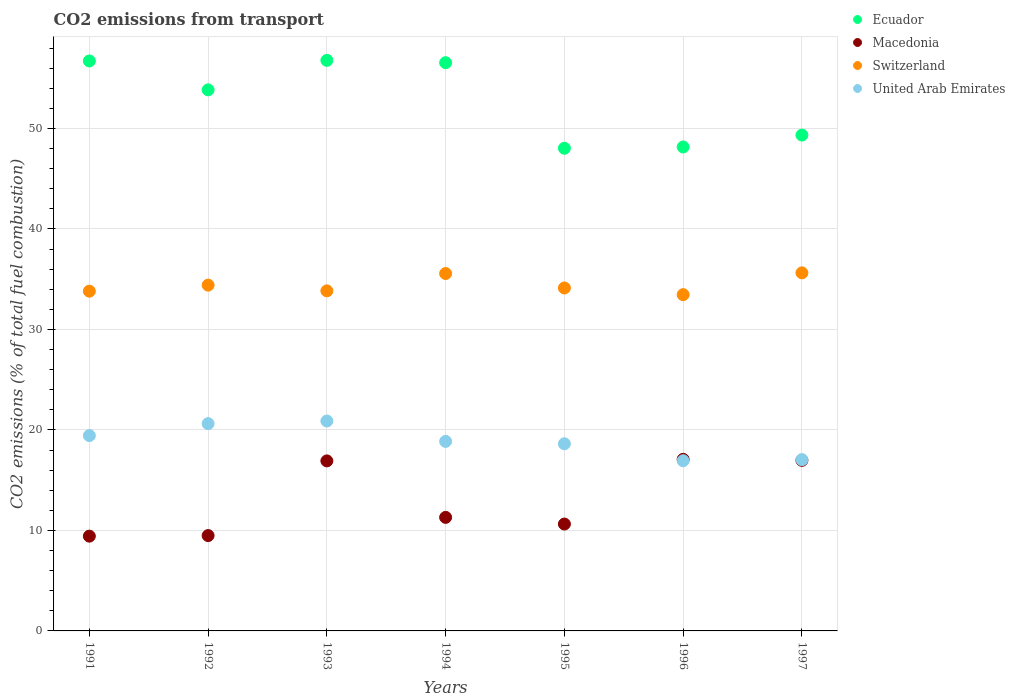How many different coloured dotlines are there?
Provide a short and direct response. 4. Is the number of dotlines equal to the number of legend labels?
Provide a short and direct response. Yes. What is the total CO2 emitted in Macedonia in 1996?
Your answer should be compact. 17.08. Across all years, what is the maximum total CO2 emitted in Macedonia?
Provide a succinct answer. 17.08. Across all years, what is the minimum total CO2 emitted in Switzerland?
Your response must be concise. 33.47. In which year was the total CO2 emitted in United Arab Emirates minimum?
Your answer should be very brief. 1996. What is the total total CO2 emitted in Ecuador in the graph?
Your answer should be compact. 369.44. What is the difference between the total CO2 emitted in Switzerland in 1994 and that in 1997?
Your answer should be compact. -0.07. What is the difference between the total CO2 emitted in Ecuador in 1994 and the total CO2 emitted in Macedonia in 1997?
Provide a succinct answer. 39.58. What is the average total CO2 emitted in United Arab Emirates per year?
Your answer should be very brief. 18.92. In the year 1996, what is the difference between the total CO2 emitted in Macedonia and total CO2 emitted in Switzerland?
Provide a short and direct response. -16.39. What is the ratio of the total CO2 emitted in Macedonia in 1992 to that in 1995?
Your answer should be compact. 0.89. Is the total CO2 emitted in United Arab Emirates in 1991 less than that in 1992?
Ensure brevity in your answer.  Yes. What is the difference between the highest and the second highest total CO2 emitted in Switzerland?
Ensure brevity in your answer.  0.07. What is the difference between the highest and the lowest total CO2 emitted in United Arab Emirates?
Your response must be concise. 3.95. What is the difference between two consecutive major ticks on the Y-axis?
Your answer should be very brief. 10. Are the values on the major ticks of Y-axis written in scientific E-notation?
Provide a short and direct response. No. Does the graph contain any zero values?
Give a very brief answer. No. Where does the legend appear in the graph?
Give a very brief answer. Top right. How many legend labels are there?
Your answer should be very brief. 4. How are the legend labels stacked?
Provide a short and direct response. Vertical. What is the title of the graph?
Your response must be concise. CO2 emissions from transport. Does "Chile" appear as one of the legend labels in the graph?
Keep it short and to the point. No. What is the label or title of the Y-axis?
Give a very brief answer. CO2 emissions (% of total fuel combustion). What is the CO2 emissions (% of total fuel combustion) of Ecuador in 1991?
Give a very brief answer. 56.72. What is the CO2 emissions (% of total fuel combustion) in Macedonia in 1991?
Your answer should be very brief. 9.43. What is the CO2 emissions (% of total fuel combustion) in Switzerland in 1991?
Provide a succinct answer. 33.81. What is the CO2 emissions (% of total fuel combustion) in United Arab Emirates in 1991?
Provide a short and direct response. 19.44. What is the CO2 emissions (% of total fuel combustion) of Ecuador in 1992?
Ensure brevity in your answer.  53.85. What is the CO2 emissions (% of total fuel combustion) in Macedonia in 1992?
Make the answer very short. 9.49. What is the CO2 emissions (% of total fuel combustion) in Switzerland in 1992?
Your answer should be very brief. 34.41. What is the CO2 emissions (% of total fuel combustion) of United Arab Emirates in 1992?
Provide a short and direct response. 20.63. What is the CO2 emissions (% of total fuel combustion) of Ecuador in 1993?
Provide a succinct answer. 56.78. What is the CO2 emissions (% of total fuel combustion) in Macedonia in 1993?
Ensure brevity in your answer.  16.92. What is the CO2 emissions (% of total fuel combustion) in Switzerland in 1993?
Make the answer very short. 33.84. What is the CO2 emissions (% of total fuel combustion) in United Arab Emirates in 1993?
Provide a short and direct response. 20.89. What is the CO2 emissions (% of total fuel combustion) in Ecuador in 1994?
Your response must be concise. 56.55. What is the CO2 emissions (% of total fuel combustion) of Macedonia in 1994?
Ensure brevity in your answer.  11.3. What is the CO2 emissions (% of total fuel combustion) in Switzerland in 1994?
Provide a short and direct response. 35.57. What is the CO2 emissions (% of total fuel combustion) of United Arab Emirates in 1994?
Offer a very short reply. 18.86. What is the CO2 emissions (% of total fuel combustion) in Ecuador in 1995?
Provide a succinct answer. 48.03. What is the CO2 emissions (% of total fuel combustion) of Macedonia in 1995?
Provide a short and direct response. 10.64. What is the CO2 emissions (% of total fuel combustion) in Switzerland in 1995?
Offer a terse response. 34.13. What is the CO2 emissions (% of total fuel combustion) of United Arab Emirates in 1995?
Your response must be concise. 18.62. What is the CO2 emissions (% of total fuel combustion) of Ecuador in 1996?
Provide a short and direct response. 48.16. What is the CO2 emissions (% of total fuel combustion) in Macedonia in 1996?
Provide a succinct answer. 17.08. What is the CO2 emissions (% of total fuel combustion) of Switzerland in 1996?
Make the answer very short. 33.47. What is the CO2 emissions (% of total fuel combustion) of United Arab Emirates in 1996?
Your answer should be very brief. 16.94. What is the CO2 emissions (% of total fuel combustion) of Ecuador in 1997?
Your answer should be very brief. 49.35. What is the CO2 emissions (% of total fuel combustion) of Macedonia in 1997?
Make the answer very short. 16.97. What is the CO2 emissions (% of total fuel combustion) in Switzerland in 1997?
Ensure brevity in your answer.  35.63. What is the CO2 emissions (% of total fuel combustion) of United Arab Emirates in 1997?
Provide a succinct answer. 17.04. Across all years, what is the maximum CO2 emissions (% of total fuel combustion) in Ecuador?
Provide a short and direct response. 56.78. Across all years, what is the maximum CO2 emissions (% of total fuel combustion) in Macedonia?
Your answer should be very brief. 17.08. Across all years, what is the maximum CO2 emissions (% of total fuel combustion) in Switzerland?
Make the answer very short. 35.63. Across all years, what is the maximum CO2 emissions (% of total fuel combustion) in United Arab Emirates?
Provide a short and direct response. 20.89. Across all years, what is the minimum CO2 emissions (% of total fuel combustion) of Ecuador?
Provide a short and direct response. 48.03. Across all years, what is the minimum CO2 emissions (% of total fuel combustion) in Macedonia?
Ensure brevity in your answer.  9.43. Across all years, what is the minimum CO2 emissions (% of total fuel combustion) of Switzerland?
Offer a very short reply. 33.47. Across all years, what is the minimum CO2 emissions (% of total fuel combustion) in United Arab Emirates?
Ensure brevity in your answer.  16.94. What is the total CO2 emissions (% of total fuel combustion) of Ecuador in the graph?
Offer a terse response. 369.44. What is the total CO2 emissions (% of total fuel combustion) in Macedonia in the graph?
Your response must be concise. 91.83. What is the total CO2 emissions (% of total fuel combustion) of Switzerland in the graph?
Offer a terse response. 240.87. What is the total CO2 emissions (% of total fuel combustion) of United Arab Emirates in the graph?
Offer a very short reply. 132.43. What is the difference between the CO2 emissions (% of total fuel combustion) of Ecuador in 1991 and that in 1992?
Give a very brief answer. 2.88. What is the difference between the CO2 emissions (% of total fuel combustion) of Macedonia in 1991 and that in 1992?
Give a very brief answer. -0.06. What is the difference between the CO2 emissions (% of total fuel combustion) in Switzerland in 1991 and that in 1992?
Ensure brevity in your answer.  -0.6. What is the difference between the CO2 emissions (% of total fuel combustion) in United Arab Emirates in 1991 and that in 1992?
Give a very brief answer. -1.19. What is the difference between the CO2 emissions (% of total fuel combustion) in Ecuador in 1991 and that in 1993?
Your answer should be compact. -0.06. What is the difference between the CO2 emissions (% of total fuel combustion) in Macedonia in 1991 and that in 1993?
Offer a terse response. -7.49. What is the difference between the CO2 emissions (% of total fuel combustion) of Switzerland in 1991 and that in 1993?
Keep it short and to the point. -0.03. What is the difference between the CO2 emissions (% of total fuel combustion) of United Arab Emirates in 1991 and that in 1993?
Ensure brevity in your answer.  -1.45. What is the difference between the CO2 emissions (% of total fuel combustion) in Ecuador in 1991 and that in 1994?
Your response must be concise. 0.17. What is the difference between the CO2 emissions (% of total fuel combustion) in Macedonia in 1991 and that in 1994?
Offer a terse response. -1.87. What is the difference between the CO2 emissions (% of total fuel combustion) in Switzerland in 1991 and that in 1994?
Make the answer very short. -1.76. What is the difference between the CO2 emissions (% of total fuel combustion) in United Arab Emirates in 1991 and that in 1994?
Give a very brief answer. 0.58. What is the difference between the CO2 emissions (% of total fuel combustion) in Ecuador in 1991 and that in 1995?
Your answer should be compact. 8.69. What is the difference between the CO2 emissions (% of total fuel combustion) of Macedonia in 1991 and that in 1995?
Your answer should be very brief. -1.2. What is the difference between the CO2 emissions (% of total fuel combustion) in Switzerland in 1991 and that in 1995?
Your response must be concise. -0.32. What is the difference between the CO2 emissions (% of total fuel combustion) in United Arab Emirates in 1991 and that in 1995?
Provide a succinct answer. 0.81. What is the difference between the CO2 emissions (% of total fuel combustion) of Ecuador in 1991 and that in 1996?
Your response must be concise. 8.56. What is the difference between the CO2 emissions (% of total fuel combustion) of Macedonia in 1991 and that in 1996?
Your answer should be very brief. -7.65. What is the difference between the CO2 emissions (% of total fuel combustion) in Switzerland in 1991 and that in 1996?
Provide a succinct answer. 0.35. What is the difference between the CO2 emissions (% of total fuel combustion) of United Arab Emirates in 1991 and that in 1996?
Your response must be concise. 2.5. What is the difference between the CO2 emissions (% of total fuel combustion) of Ecuador in 1991 and that in 1997?
Your answer should be very brief. 7.38. What is the difference between the CO2 emissions (% of total fuel combustion) in Macedonia in 1991 and that in 1997?
Provide a succinct answer. -7.54. What is the difference between the CO2 emissions (% of total fuel combustion) in Switzerland in 1991 and that in 1997?
Give a very brief answer. -1.82. What is the difference between the CO2 emissions (% of total fuel combustion) in United Arab Emirates in 1991 and that in 1997?
Give a very brief answer. 2.39. What is the difference between the CO2 emissions (% of total fuel combustion) of Ecuador in 1992 and that in 1993?
Give a very brief answer. -2.94. What is the difference between the CO2 emissions (% of total fuel combustion) in Macedonia in 1992 and that in 1993?
Ensure brevity in your answer.  -7.43. What is the difference between the CO2 emissions (% of total fuel combustion) in Switzerland in 1992 and that in 1993?
Your response must be concise. 0.57. What is the difference between the CO2 emissions (% of total fuel combustion) of United Arab Emirates in 1992 and that in 1993?
Offer a very short reply. -0.26. What is the difference between the CO2 emissions (% of total fuel combustion) of Ecuador in 1992 and that in 1994?
Provide a short and direct response. -2.7. What is the difference between the CO2 emissions (% of total fuel combustion) in Macedonia in 1992 and that in 1994?
Your response must be concise. -1.81. What is the difference between the CO2 emissions (% of total fuel combustion) in Switzerland in 1992 and that in 1994?
Provide a short and direct response. -1.15. What is the difference between the CO2 emissions (% of total fuel combustion) of United Arab Emirates in 1992 and that in 1994?
Provide a succinct answer. 1.77. What is the difference between the CO2 emissions (% of total fuel combustion) of Ecuador in 1992 and that in 1995?
Make the answer very short. 5.81. What is the difference between the CO2 emissions (% of total fuel combustion) in Macedonia in 1992 and that in 1995?
Provide a succinct answer. -1.15. What is the difference between the CO2 emissions (% of total fuel combustion) of Switzerland in 1992 and that in 1995?
Ensure brevity in your answer.  0.28. What is the difference between the CO2 emissions (% of total fuel combustion) of United Arab Emirates in 1992 and that in 1995?
Give a very brief answer. 2. What is the difference between the CO2 emissions (% of total fuel combustion) of Ecuador in 1992 and that in 1996?
Offer a terse response. 5.68. What is the difference between the CO2 emissions (% of total fuel combustion) of Macedonia in 1992 and that in 1996?
Your answer should be very brief. -7.59. What is the difference between the CO2 emissions (% of total fuel combustion) in Switzerland in 1992 and that in 1996?
Offer a very short reply. 0.95. What is the difference between the CO2 emissions (% of total fuel combustion) in United Arab Emirates in 1992 and that in 1996?
Make the answer very short. 3.69. What is the difference between the CO2 emissions (% of total fuel combustion) of Ecuador in 1992 and that in 1997?
Give a very brief answer. 4.5. What is the difference between the CO2 emissions (% of total fuel combustion) in Macedonia in 1992 and that in 1997?
Ensure brevity in your answer.  -7.49. What is the difference between the CO2 emissions (% of total fuel combustion) in Switzerland in 1992 and that in 1997?
Provide a succinct answer. -1.22. What is the difference between the CO2 emissions (% of total fuel combustion) in United Arab Emirates in 1992 and that in 1997?
Provide a succinct answer. 3.58. What is the difference between the CO2 emissions (% of total fuel combustion) of Ecuador in 1993 and that in 1994?
Your answer should be compact. 0.23. What is the difference between the CO2 emissions (% of total fuel combustion) in Macedonia in 1993 and that in 1994?
Make the answer very short. 5.62. What is the difference between the CO2 emissions (% of total fuel combustion) of Switzerland in 1993 and that in 1994?
Provide a short and direct response. -1.73. What is the difference between the CO2 emissions (% of total fuel combustion) of United Arab Emirates in 1993 and that in 1994?
Give a very brief answer. 2.03. What is the difference between the CO2 emissions (% of total fuel combustion) in Ecuador in 1993 and that in 1995?
Your answer should be compact. 8.75. What is the difference between the CO2 emissions (% of total fuel combustion) in Macedonia in 1993 and that in 1995?
Offer a terse response. 6.29. What is the difference between the CO2 emissions (% of total fuel combustion) of Switzerland in 1993 and that in 1995?
Offer a very short reply. -0.29. What is the difference between the CO2 emissions (% of total fuel combustion) in United Arab Emirates in 1993 and that in 1995?
Your response must be concise. 2.27. What is the difference between the CO2 emissions (% of total fuel combustion) in Ecuador in 1993 and that in 1996?
Ensure brevity in your answer.  8.62. What is the difference between the CO2 emissions (% of total fuel combustion) of Macedonia in 1993 and that in 1996?
Give a very brief answer. -0.16. What is the difference between the CO2 emissions (% of total fuel combustion) in Switzerland in 1993 and that in 1996?
Offer a very short reply. 0.38. What is the difference between the CO2 emissions (% of total fuel combustion) in United Arab Emirates in 1993 and that in 1996?
Give a very brief answer. 3.95. What is the difference between the CO2 emissions (% of total fuel combustion) of Ecuador in 1993 and that in 1997?
Your answer should be very brief. 7.44. What is the difference between the CO2 emissions (% of total fuel combustion) of Macedonia in 1993 and that in 1997?
Your answer should be compact. -0.05. What is the difference between the CO2 emissions (% of total fuel combustion) in Switzerland in 1993 and that in 1997?
Offer a very short reply. -1.79. What is the difference between the CO2 emissions (% of total fuel combustion) in United Arab Emirates in 1993 and that in 1997?
Your answer should be compact. 3.85. What is the difference between the CO2 emissions (% of total fuel combustion) of Ecuador in 1994 and that in 1995?
Your answer should be very brief. 8.52. What is the difference between the CO2 emissions (% of total fuel combustion) of Macedonia in 1994 and that in 1995?
Ensure brevity in your answer.  0.66. What is the difference between the CO2 emissions (% of total fuel combustion) in Switzerland in 1994 and that in 1995?
Your answer should be very brief. 1.44. What is the difference between the CO2 emissions (% of total fuel combustion) of United Arab Emirates in 1994 and that in 1995?
Ensure brevity in your answer.  0.24. What is the difference between the CO2 emissions (% of total fuel combustion) of Ecuador in 1994 and that in 1996?
Ensure brevity in your answer.  8.39. What is the difference between the CO2 emissions (% of total fuel combustion) of Macedonia in 1994 and that in 1996?
Provide a succinct answer. -5.78. What is the difference between the CO2 emissions (% of total fuel combustion) in Switzerland in 1994 and that in 1996?
Ensure brevity in your answer.  2.1. What is the difference between the CO2 emissions (% of total fuel combustion) in United Arab Emirates in 1994 and that in 1996?
Offer a very short reply. 1.92. What is the difference between the CO2 emissions (% of total fuel combustion) of Ecuador in 1994 and that in 1997?
Offer a terse response. 7.2. What is the difference between the CO2 emissions (% of total fuel combustion) in Macedonia in 1994 and that in 1997?
Your answer should be very brief. -5.67. What is the difference between the CO2 emissions (% of total fuel combustion) in Switzerland in 1994 and that in 1997?
Offer a terse response. -0.07. What is the difference between the CO2 emissions (% of total fuel combustion) of United Arab Emirates in 1994 and that in 1997?
Make the answer very short. 1.82. What is the difference between the CO2 emissions (% of total fuel combustion) in Ecuador in 1995 and that in 1996?
Your response must be concise. -0.13. What is the difference between the CO2 emissions (% of total fuel combustion) of Macedonia in 1995 and that in 1996?
Your response must be concise. -6.44. What is the difference between the CO2 emissions (% of total fuel combustion) of Switzerland in 1995 and that in 1996?
Your answer should be very brief. 0.66. What is the difference between the CO2 emissions (% of total fuel combustion) of United Arab Emirates in 1995 and that in 1996?
Keep it short and to the point. 1.69. What is the difference between the CO2 emissions (% of total fuel combustion) in Ecuador in 1995 and that in 1997?
Provide a short and direct response. -1.31. What is the difference between the CO2 emissions (% of total fuel combustion) in Macedonia in 1995 and that in 1997?
Give a very brief answer. -6.34. What is the difference between the CO2 emissions (% of total fuel combustion) of Switzerland in 1995 and that in 1997?
Offer a very short reply. -1.5. What is the difference between the CO2 emissions (% of total fuel combustion) in United Arab Emirates in 1995 and that in 1997?
Offer a very short reply. 1.58. What is the difference between the CO2 emissions (% of total fuel combustion) in Ecuador in 1996 and that in 1997?
Ensure brevity in your answer.  -1.18. What is the difference between the CO2 emissions (% of total fuel combustion) in Macedonia in 1996 and that in 1997?
Your response must be concise. 0.1. What is the difference between the CO2 emissions (% of total fuel combustion) of Switzerland in 1996 and that in 1997?
Ensure brevity in your answer.  -2.17. What is the difference between the CO2 emissions (% of total fuel combustion) in United Arab Emirates in 1996 and that in 1997?
Ensure brevity in your answer.  -0.11. What is the difference between the CO2 emissions (% of total fuel combustion) of Ecuador in 1991 and the CO2 emissions (% of total fuel combustion) of Macedonia in 1992?
Make the answer very short. 47.23. What is the difference between the CO2 emissions (% of total fuel combustion) in Ecuador in 1991 and the CO2 emissions (% of total fuel combustion) in Switzerland in 1992?
Your answer should be very brief. 22.31. What is the difference between the CO2 emissions (% of total fuel combustion) of Ecuador in 1991 and the CO2 emissions (% of total fuel combustion) of United Arab Emirates in 1992?
Make the answer very short. 36.1. What is the difference between the CO2 emissions (% of total fuel combustion) of Macedonia in 1991 and the CO2 emissions (% of total fuel combustion) of Switzerland in 1992?
Your answer should be very brief. -24.98. What is the difference between the CO2 emissions (% of total fuel combustion) of Macedonia in 1991 and the CO2 emissions (% of total fuel combustion) of United Arab Emirates in 1992?
Your answer should be very brief. -11.2. What is the difference between the CO2 emissions (% of total fuel combustion) of Switzerland in 1991 and the CO2 emissions (% of total fuel combustion) of United Arab Emirates in 1992?
Offer a terse response. 13.18. What is the difference between the CO2 emissions (% of total fuel combustion) of Ecuador in 1991 and the CO2 emissions (% of total fuel combustion) of Macedonia in 1993?
Give a very brief answer. 39.8. What is the difference between the CO2 emissions (% of total fuel combustion) of Ecuador in 1991 and the CO2 emissions (% of total fuel combustion) of Switzerland in 1993?
Offer a terse response. 22.88. What is the difference between the CO2 emissions (% of total fuel combustion) of Ecuador in 1991 and the CO2 emissions (% of total fuel combustion) of United Arab Emirates in 1993?
Your answer should be very brief. 35.83. What is the difference between the CO2 emissions (% of total fuel combustion) in Macedonia in 1991 and the CO2 emissions (% of total fuel combustion) in Switzerland in 1993?
Provide a succinct answer. -24.41. What is the difference between the CO2 emissions (% of total fuel combustion) of Macedonia in 1991 and the CO2 emissions (% of total fuel combustion) of United Arab Emirates in 1993?
Keep it short and to the point. -11.46. What is the difference between the CO2 emissions (% of total fuel combustion) of Switzerland in 1991 and the CO2 emissions (% of total fuel combustion) of United Arab Emirates in 1993?
Your answer should be very brief. 12.92. What is the difference between the CO2 emissions (% of total fuel combustion) of Ecuador in 1991 and the CO2 emissions (% of total fuel combustion) of Macedonia in 1994?
Make the answer very short. 45.42. What is the difference between the CO2 emissions (% of total fuel combustion) of Ecuador in 1991 and the CO2 emissions (% of total fuel combustion) of Switzerland in 1994?
Offer a very short reply. 21.16. What is the difference between the CO2 emissions (% of total fuel combustion) of Ecuador in 1991 and the CO2 emissions (% of total fuel combustion) of United Arab Emirates in 1994?
Offer a terse response. 37.86. What is the difference between the CO2 emissions (% of total fuel combustion) in Macedonia in 1991 and the CO2 emissions (% of total fuel combustion) in Switzerland in 1994?
Your answer should be very brief. -26.14. What is the difference between the CO2 emissions (% of total fuel combustion) of Macedonia in 1991 and the CO2 emissions (% of total fuel combustion) of United Arab Emirates in 1994?
Keep it short and to the point. -9.43. What is the difference between the CO2 emissions (% of total fuel combustion) in Switzerland in 1991 and the CO2 emissions (% of total fuel combustion) in United Arab Emirates in 1994?
Give a very brief answer. 14.95. What is the difference between the CO2 emissions (% of total fuel combustion) in Ecuador in 1991 and the CO2 emissions (% of total fuel combustion) in Macedonia in 1995?
Your answer should be very brief. 46.09. What is the difference between the CO2 emissions (% of total fuel combustion) in Ecuador in 1991 and the CO2 emissions (% of total fuel combustion) in Switzerland in 1995?
Offer a very short reply. 22.59. What is the difference between the CO2 emissions (% of total fuel combustion) of Ecuador in 1991 and the CO2 emissions (% of total fuel combustion) of United Arab Emirates in 1995?
Your answer should be compact. 38.1. What is the difference between the CO2 emissions (% of total fuel combustion) of Macedonia in 1991 and the CO2 emissions (% of total fuel combustion) of Switzerland in 1995?
Keep it short and to the point. -24.7. What is the difference between the CO2 emissions (% of total fuel combustion) of Macedonia in 1991 and the CO2 emissions (% of total fuel combustion) of United Arab Emirates in 1995?
Keep it short and to the point. -9.19. What is the difference between the CO2 emissions (% of total fuel combustion) in Switzerland in 1991 and the CO2 emissions (% of total fuel combustion) in United Arab Emirates in 1995?
Offer a terse response. 15.19. What is the difference between the CO2 emissions (% of total fuel combustion) of Ecuador in 1991 and the CO2 emissions (% of total fuel combustion) of Macedonia in 1996?
Your answer should be very brief. 39.65. What is the difference between the CO2 emissions (% of total fuel combustion) in Ecuador in 1991 and the CO2 emissions (% of total fuel combustion) in Switzerland in 1996?
Offer a very short reply. 23.26. What is the difference between the CO2 emissions (% of total fuel combustion) in Ecuador in 1991 and the CO2 emissions (% of total fuel combustion) in United Arab Emirates in 1996?
Your answer should be compact. 39.79. What is the difference between the CO2 emissions (% of total fuel combustion) of Macedonia in 1991 and the CO2 emissions (% of total fuel combustion) of Switzerland in 1996?
Offer a terse response. -24.03. What is the difference between the CO2 emissions (% of total fuel combustion) of Macedonia in 1991 and the CO2 emissions (% of total fuel combustion) of United Arab Emirates in 1996?
Provide a short and direct response. -7.51. What is the difference between the CO2 emissions (% of total fuel combustion) of Switzerland in 1991 and the CO2 emissions (% of total fuel combustion) of United Arab Emirates in 1996?
Offer a terse response. 16.87. What is the difference between the CO2 emissions (% of total fuel combustion) in Ecuador in 1991 and the CO2 emissions (% of total fuel combustion) in Macedonia in 1997?
Give a very brief answer. 39.75. What is the difference between the CO2 emissions (% of total fuel combustion) of Ecuador in 1991 and the CO2 emissions (% of total fuel combustion) of Switzerland in 1997?
Give a very brief answer. 21.09. What is the difference between the CO2 emissions (% of total fuel combustion) of Ecuador in 1991 and the CO2 emissions (% of total fuel combustion) of United Arab Emirates in 1997?
Provide a succinct answer. 39.68. What is the difference between the CO2 emissions (% of total fuel combustion) of Macedonia in 1991 and the CO2 emissions (% of total fuel combustion) of Switzerland in 1997?
Keep it short and to the point. -26.2. What is the difference between the CO2 emissions (% of total fuel combustion) of Macedonia in 1991 and the CO2 emissions (% of total fuel combustion) of United Arab Emirates in 1997?
Provide a succinct answer. -7.61. What is the difference between the CO2 emissions (% of total fuel combustion) of Switzerland in 1991 and the CO2 emissions (% of total fuel combustion) of United Arab Emirates in 1997?
Offer a terse response. 16.77. What is the difference between the CO2 emissions (% of total fuel combustion) in Ecuador in 1992 and the CO2 emissions (% of total fuel combustion) in Macedonia in 1993?
Your response must be concise. 36.92. What is the difference between the CO2 emissions (% of total fuel combustion) of Ecuador in 1992 and the CO2 emissions (% of total fuel combustion) of Switzerland in 1993?
Offer a terse response. 20. What is the difference between the CO2 emissions (% of total fuel combustion) of Ecuador in 1992 and the CO2 emissions (% of total fuel combustion) of United Arab Emirates in 1993?
Your response must be concise. 32.95. What is the difference between the CO2 emissions (% of total fuel combustion) in Macedonia in 1992 and the CO2 emissions (% of total fuel combustion) in Switzerland in 1993?
Make the answer very short. -24.35. What is the difference between the CO2 emissions (% of total fuel combustion) of Macedonia in 1992 and the CO2 emissions (% of total fuel combustion) of United Arab Emirates in 1993?
Provide a succinct answer. -11.4. What is the difference between the CO2 emissions (% of total fuel combustion) of Switzerland in 1992 and the CO2 emissions (% of total fuel combustion) of United Arab Emirates in 1993?
Provide a succinct answer. 13.52. What is the difference between the CO2 emissions (% of total fuel combustion) in Ecuador in 1992 and the CO2 emissions (% of total fuel combustion) in Macedonia in 1994?
Offer a very short reply. 42.55. What is the difference between the CO2 emissions (% of total fuel combustion) of Ecuador in 1992 and the CO2 emissions (% of total fuel combustion) of Switzerland in 1994?
Offer a terse response. 18.28. What is the difference between the CO2 emissions (% of total fuel combustion) in Ecuador in 1992 and the CO2 emissions (% of total fuel combustion) in United Arab Emirates in 1994?
Make the answer very short. 34.98. What is the difference between the CO2 emissions (% of total fuel combustion) in Macedonia in 1992 and the CO2 emissions (% of total fuel combustion) in Switzerland in 1994?
Ensure brevity in your answer.  -26.08. What is the difference between the CO2 emissions (% of total fuel combustion) in Macedonia in 1992 and the CO2 emissions (% of total fuel combustion) in United Arab Emirates in 1994?
Your answer should be compact. -9.37. What is the difference between the CO2 emissions (% of total fuel combustion) in Switzerland in 1992 and the CO2 emissions (% of total fuel combustion) in United Arab Emirates in 1994?
Provide a succinct answer. 15.55. What is the difference between the CO2 emissions (% of total fuel combustion) in Ecuador in 1992 and the CO2 emissions (% of total fuel combustion) in Macedonia in 1995?
Keep it short and to the point. 43.21. What is the difference between the CO2 emissions (% of total fuel combustion) in Ecuador in 1992 and the CO2 emissions (% of total fuel combustion) in Switzerland in 1995?
Offer a very short reply. 19.72. What is the difference between the CO2 emissions (% of total fuel combustion) in Ecuador in 1992 and the CO2 emissions (% of total fuel combustion) in United Arab Emirates in 1995?
Provide a short and direct response. 35.22. What is the difference between the CO2 emissions (% of total fuel combustion) of Macedonia in 1992 and the CO2 emissions (% of total fuel combustion) of Switzerland in 1995?
Provide a succinct answer. -24.64. What is the difference between the CO2 emissions (% of total fuel combustion) in Macedonia in 1992 and the CO2 emissions (% of total fuel combustion) in United Arab Emirates in 1995?
Provide a succinct answer. -9.14. What is the difference between the CO2 emissions (% of total fuel combustion) of Switzerland in 1992 and the CO2 emissions (% of total fuel combustion) of United Arab Emirates in 1995?
Offer a very short reply. 15.79. What is the difference between the CO2 emissions (% of total fuel combustion) in Ecuador in 1992 and the CO2 emissions (% of total fuel combustion) in Macedonia in 1996?
Make the answer very short. 36.77. What is the difference between the CO2 emissions (% of total fuel combustion) in Ecuador in 1992 and the CO2 emissions (% of total fuel combustion) in Switzerland in 1996?
Make the answer very short. 20.38. What is the difference between the CO2 emissions (% of total fuel combustion) of Ecuador in 1992 and the CO2 emissions (% of total fuel combustion) of United Arab Emirates in 1996?
Offer a very short reply. 36.91. What is the difference between the CO2 emissions (% of total fuel combustion) of Macedonia in 1992 and the CO2 emissions (% of total fuel combustion) of Switzerland in 1996?
Your response must be concise. -23.98. What is the difference between the CO2 emissions (% of total fuel combustion) of Macedonia in 1992 and the CO2 emissions (% of total fuel combustion) of United Arab Emirates in 1996?
Offer a very short reply. -7.45. What is the difference between the CO2 emissions (% of total fuel combustion) of Switzerland in 1992 and the CO2 emissions (% of total fuel combustion) of United Arab Emirates in 1996?
Make the answer very short. 17.48. What is the difference between the CO2 emissions (% of total fuel combustion) in Ecuador in 1992 and the CO2 emissions (% of total fuel combustion) in Macedonia in 1997?
Your response must be concise. 36.87. What is the difference between the CO2 emissions (% of total fuel combustion) in Ecuador in 1992 and the CO2 emissions (% of total fuel combustion) in Switzerland in 1997?
Provide a short and direct response. 18.21. What is the difference between the CO2 emissions (% of total fuel combustion) in Ecuador in 1992 and the CO2 emissions (% of total fuel combustion) in United Arab Emirates in 1997?
Offer a terse response. 36.8. What is the difference between the CO2 emissions (% of total fuel combustion) in Macedonia in 1992 and the CO2 emissions (% of total fuel combustion) in Switzerland in 1997?
Your response must be concise. -26.15. What is the difference between the CO2 emissions (% of total fuel combustion) of Macedonia in 1992 and the CO2 emissions (% of total fuel combustion) of United Arab Emirates in 1997?
Provide a succinct answer. -7.56. What is the difference between the CO2 emissions (% of total fuel combustion) in Switzerland in 1992 and the CO2 emissions (% of total fuel combustion) in United Arab Emirates in 1997?
Your answer should be compact. 17.37. What is the difference between the CO2 emissions (% of total fuel combustion) in Ecuador in 1993 and the CO2 emissions (% of total fuel combustion) in Macedonia in 1994?
Offer a terse response. 45.48. What is the difference between the CO2 emissions (% of total fuel combustion) of Ecuador in 1993 and the CO2 emissions (% of total fuel combustion) of Switzerland in 1994?
Ensure brevity in your answer.  21.21. What is the difference between the CO2 emissions (% of total fuel combustion) in Ecuador in 1993 and the CO2 emissions (% of total fuel combustion) in United Arab Emirates in 1994?
Your response must be concise. 37.92. What is the difference between the CO2 emissions (% of total fuel combustion) in Macedonia in 1993 and the CO2 emissions (% of total fuel combustion) in Switzerland in 1994?
Your response must be concise. -18.65. What is the difference between the CO2 emissions (% of total fuel combustion) of Macedonia in 1993 and the CO2 emissions (% of total fuel combustion) of United Arab Emirates in 1994?
Make the answer very short. -1.94. What is the difference between the CO2 emissions (% of total fuel combustion) of Switzerland in 1993 and the CO2 emissions (% of total fuel combustion) of United Arab Emirates in 1994?
Give a very brief answer. 14.98. What is the difference between the CO2 emissions (% of total fuel combustion) in Ecuador in 1993 and the CO2 emissions (% of total fuel combustion) in Macedonia in 1995?
Your answer should be compact. 46.15. What is the difference between the CO2 emissions (% of total fuel combustion) in Ecuador in 1993 and the CO2 emissions (% of total fuel combustion) in Switzerland in 1995?
Provide a succinct answer. 22.65. What is the difference between the CO2 emissions (% of total fuel combustion) in Ecuador in 1993 and the CO2 emissions (% of total fuel combustion) in United Arab Emirates in 1995?
Make the answer very short. 38.16. What is the difference between the CO2 emissions (% of total fuel combustion) in Macedonia in 1993 and the CO2 emissions (% of total fuel combustion) in Switzerland in 1995?
Your response must be concise. -17.21. What is the difference between the CO2 emissions (% of total fuel combustion) in Macedonia in 1993 and the CO2 emissions (% of total fuel combustion) in United Arab Emirates in 1995?
Your answer should be compact. -1.7. What is the difference between the CO2 emissions (% of total fuel combustion) of Switzerland in 1993 and the CO2 emissions (% of total fuel combustion) of United Arab Emirates in 1995?
Ensure brevity in your answer.  15.22. What is the difference between the CO2 emissions (% of total fuel combustion) in Ecuador in 1993 and the CO2 emissions (% of total fuel combustion) in Macedonia in 1996?
Your answer should be compact. 39.7. What is the difference between the CO2 emissions (% of total fuel combustion) of Ecuador in 1993 and the CO2 emissions (% of total fuel combustion) of Switzerland in 1996?
Give a very brief answer. 23.32. What is the difference between the CO2 emissions (% of total fuel combustion) in Ecuador in 1993 and the CO2 emissions (% of total fuel combustion) in United Arab Emirates in 1996?
Offer a very short reply. 39.84. What is the difference between the CO2 emissions (% of total fuel combustion) of Macedonia in 1993 and the CO2 emissions (% of total fuel combustion) of Switzerland in 1996?
Your answer should be compact. -16.54. What is the difference between the CO2 emissions (% of total fuel combustion) of Macedonia in 1993 and the CO2 emissions (% of total fuel combustion) of United Arab Emirates in 1996?
Keep it short and to the point. -0.02. What is the difference between the CO2 emissions (% of total fuel combustion) of Switzerland in 1993 and the CO2 emissions (% of total fuel combustion) of United Arab Emirates in 1996?
Keep it short and to the point. 16.9. What is the difference between the CO2 emissions (% of total fuel combustion) of Ecuador in 1993 and the CO2 emissions (% of total fuel combustion) of Macedonia in 1997?
Keep it short and to the point. 39.81. What is the difference between the CO2 emissions (% of total fuel combustion) in Ecuador in 1993 and the CO2 emissions (% of total fuel combustion) in Switzerland in 1997?
Offer a very short reply. 21.15. What is the difference between the CO2 emissions (% of total fuel combustion) in Ecuador in 1993 and the CO2 emissions (% of total fuel combustion) in United Arab Emirates in 1997?
Make the answer very short. 39.74. What is the difference between the CO2 emissions (% of total fuel combustion) of Macedonia in 1993 and the CO2 emissions (% of total fuel combustion) of Switzerland in 1997?
Ensure brevity in your answer.  -18.71. What is the difference between the CO2 emissions (% of total fuel combustion) in Macedonia in 1993 and the CO2 emissions (% of total fuel combustion) in United Arab Emirates in 1997?
Your response must be concise. -0.12. What is the difference between the CO2 emissions (% of total fuel combustion) of Switzerland in 1993 and the CO2 emissions (% of total fuel combustion) of United Arab Emirates in 1997?
Provide a short and direct response. 16.8. What is the difference between the CO2 emissions (% of total fuel combustion) in Ecuador in 1994 and the CO2 emissions (% of total fuel combustion) in Macedonia in 1995?
Your response must be concise. 45.91. What is the difference between the CO2 emissions (% of total fuel combustion) of Ecuador in 1994 and the CO2 emissions (% of total fuel combustion) of Switzerland in 1995?
Your answer should be very brief. 22.42. What is the difference between the CO2 emissions (% of total fuel combustion) in Ecuador in 1994 and the CO2 emissions (% of total fuel combustion) in United Arab Emirates in 1995?
Provide a succinct answer. 37.93. What is the difference between the CO2 emissions (% of total fuel combustion) in Macedonia in 1994 and the CO2 emissions (% of total fuel combustion) in Switzerland in 1995?
Make the answer very short. -22.83. What is the difference between the CO2 emissions (% of total fuel combustion) in Macedonia in 1994 and the CO2 emissions (% of total fuel combustion) in United Arab Emirates in 1995?
Your answer should be very brief. -7.32. What is the difference between the CO2 emissions (% of total fuel combustion) in Switzerland in 1994 and the CO2 emissions (% of total fuel combustion) in United Arab Emirates in 1995?
Provide a succinct answer. 16.94. What is the difference between the CO2 emissions (% of total fuel combustion) in Ecuador in 1994 and the CO2 emissions (% of total fuel combustion) in Macedonia in 1996?
Ensure brevity in your answer.  39.47. What is the difference between the CO2 emissions (% of total fuel combustion) in Ecuador in 1994 and the CO2 emissions (% of total fuel combustion) in Switzerland in 1996?
Offer a very short reply. 23.08. What is the difference between the CO2 emissions (% of total fuel combustion) of Ecuador in 1994 and the CO2 emissions (% of total fuel combustion) of United Arab Emirates in 1996?
Keep it short and to the point. 39.61. What is the difference between the CO2 emissions (% of total fuel combustion) in Macedonia in 1994 and the CO2 emissions (% of total fuel combustion) in Switzerland in 1996?
Provide a short and direct response. -22.17. What is the difference between the CO2 emissions (% of total fuel combustion) in Macedonia in 1994 and the CO2 emissions (% of total fuel combustion) in United Arab Emirates in 1996?
Offer a terse response. -5.64. What is the difference between the CO2 emissions (% of total fuel combustion) in Switzerland in 1994 and the CO2 emissions (% of total fuel combustion) in United Arab Emirates in 1996?
Your answer should be very brief. 18.63. What is the difference between the CO2 emissions (% of total fuel combustion) in Ecuador in 1994 and the CO2 emissions (% of total fuel combustion) in Macedonia in 1997?
Give a very brief answer. 39.58. What is the difference between the CO2 emissions (% of total fuel combustion) in Ecuador in 1994 and the CO2 emissions (% of total fuel combustion) in Switzerland in 1997?
Provide a short and direct response. 20.92. What is the difference between the CO2 emissions (% of total fuel combustion) in Ecuador in 1994 and the CO2 emissions (% of total fuel combustion) in United Arab Emirates in 1997?
Keep it short and to the point. 39.51. What is the difference between the CO2 emissions (% of total fuel combustion) in Macedonia in 1994 and the CO2 emissions (% of total fuel combustion) in Switzerland in 1997?
Provide a short and direct response. -24.33. What is the difference between the CO2 emissions (% of total fuel combustion) in Macedonia in 1994 and the CO2 emissions (% of total fuel combustion) in United Arab Emirates in 1997?
Your answer should be compact. -5.74. What is the difference between the CO2 emissions (% of total fuel combustion) of Switzerland in 1994 and the CO2 emissions (% of total fuel combustion) of United Arab Emirates in 1997?
Provide a short and direct response. 18.52. What is the difference between the CO2 emissions (% of total fuel combustion) in Ecuador in 1995 and the CO2 emissions (% of total fuel combustion) in Macedonia in 1996?
Make the answer very short. 30.95. What is the difference between the CO2 emissions (% of total fuel combustion) in Ecuador in 1995 and the CO2 emissions (% of total fuel combustion) in Switzerland in 1996?
Your answer should be very brief. 14.57. What is the difference between the CO2 emissions (% of total fuel combustion) of Ecuador in 1995 and the CO2 emissions (% of total fuel combustion) of United Arab Emirates in 1996?
Ensure brevity in your answer.  31.1. What is the difference between the CO2 emissions (% of total fuel combustion) of Macedonia in 1995 and the CO2 emissions (% of total fuel combustion) of Switzerland in 1996?
Offer a terse response. -22.83. What is the difference between the CO2 emissions (% of total fuel combustion) in Macedonia in 1995 and the CO2 emissions (% of total fuel combustion) in United Arab Emirates in 1996?
Keep it short and to the point. -6.3. What is the difference between the CO2 emissions (% of total fuel combustion) of Switzerland in 1995 and the CO2 emissions (% of total fuel combustion) of United Arab Emirates in 1996?
Offer a terse response. 17.19. What is the difference between the CO2 emissions (% of total fuel combustion) in Ecuador in 1995 and the CO2 emissions (% of total fuel combustion) in Macedonia in 1997?
Provide a short and direct response. 31.06. What is the difference between the CO2 emissions (% of total fuel combustion) in Ecuador in 1995 and the CO2 emissions (% of total fuel combustion) in Switzerland in 1997?
Keep it short and to the point. 12.4. What is the difference between the CO2 emissions (% of total fuel combustion) of Ecuador in 1995 and the CO2 emissions (% of total fuel combustion) of United Arab Emirates in 1997?
Provide a succinct answer. 30.99. What is the difference between the CO2 emissions (% of total fuel combustion) of Macedonia in 1995 and the CO2 emissions (% of total fuel combustion) of Switzerland in 1997?
Provide a short and direct response. -25. What is the difference between the CO2 emissions (% of total fuel combustion) in Macedonia in 1995 and the CO2 emissions (% of total fuel combustion) in United Arab Emirates in 1997?
Your answer should be compact. -6.41. What is the difference between the CO2 emissions (% of total fuel combustion) of Switzerland in 1995 and the CO2 emissions (% of total fuel combustion) of United Arab Emirates in 1997?
Give a very brief answer. 17.09. What is the difference between the CO2 emissions (% of total fuel combustion) of Ecuador in 1996 and the CO2 emissions (% of total fuel combustion) of Macedonia in 1997?
Ensure brevity in your answer.  31.19. What is the difference between the CO2 emissions (% of total fuel combustion) of Ecuador in 1996 and the CO2 emissions (% of total fuel combustion) of Switzerland in 1997?
Provide a short and direct response. 12.53. What is the difference between the CO2 emissions (% of total fuel combustion) in Ecuador in 1996 and the CO2 emissions (% of total fuel combustion) in United Arab Emirates in 1997?
Give a very brief answer. 31.12. What is the difference between the CO2 emissions (% of total fuel combustion) of Macedonia in 1996 and the CO2 emissions (% of total fuel combustion) of Switzerland in 1997?
Provide a short and direct response. -18.56. What is the difference between the CO2 emissions (% of total fuel combustion) of Macedonia in 1996 and the CO2 emissions (% of total fuel combustion) of United Arab Emirates in 1997?
Give a very brief answer. 0.03. What is the difference between the CO2 emissions (% of total fuel combustion) of Switzerland in 1996 and the CO2 emissions (% of total fuel combustion) of United Arab Emirates in 1997?
Keep it short and to the point. 16.42. What is the average CO2 emissions (% of total fuel combustion) in Ecuador per year?
Ensure brevity in your answer.  52.78. What is the average CO2 emissions (% of total fuel combustion) of Macedonia per year?
Your answer should be very brief. 13.12. What is the average CO2 emissions (% of total fuel combustion) of Switzerland per year?
Provide a short and direct response. 34.41. What is the average CO2 emissions (% of total fuel combustion) in United Arab Emirates per year?
Provide a succinct answer. 18.92. In the year 1991, what is the difference between the CO2 emissions (% of total fuel combustion) in Ecuador and CO2 emissions (% of total fuel combustion) in Macedonia?
Offer a very short reply. 47.29. In the year 1991, what is the difference between the CO2 emissions (% of total fuel combustion) of Ecuador and CO2 emissions (% of total fuel combustion) of Switzerland?
Give a very brief answer. 22.91. In the year 1991, what is the difference between the CO2 emissions (% of total fuel combustion) in Ecuador and CO2 emissions (% of total fuel combustion) in United Arab Emirates?
Your response must be concise. 37.29. In the year 1991, what is the difference between the CO2 emissions (% of total fuel combustion) in Macedonia and CO2 emissions (% of total fuel combustion) in Switzerland?
Provide a succinct answer. -24.38. In the year 1991, what is the difference between the CO2 emissions (% of total fuel combustion) in Macedonia and CO2 emissions (% of total fuel combustion) in United Arab Emirates?
Your answer should be compact. -10.01. In the year 1991, what is the difference between the CO2 emissions (% of total fuel combustion) in Switzerland and CO2 emissions (% of total fuel combustion) in United Arab Emirates?
Offer a very short reply. 14.37. In the year 1992, what is the difference between the CO2 emissions (% of total fuel combustion) in Ecuador and CO2 emissions (% of total fuel combustion) in Macedonia?
Your answer should be compact. 44.36. In the year 1992, what is the difference between the CO2 emissions (% of total fuel combustion) in Ecuador and CO2 emissions (% of total fuel combustion) in Switzerland?
Offer a terse response. 19.43. In the year 1992, what is the difference between the CO2 emissions (% of total fuel combustion) of Ecuador and CO2 emissions (% of total fuel combustion) of United Arab Emirates?
Your response must be concise. 33.22. In the year 1992, what is the difference between the CO2 emissions (% of total fuel combustion) in Macedonia and CO2 emissions (% of total fuel combustion) in Switzerland?
Your answer should be very brief. -24.92. In the year 1992, what is the difference between the CO2 emissions (% of total fuel combustion) of Macedonia and CO2 emissions (% of total fuel combustion) of United Arab Emirates?
Keep it short and to the point. -11.14. In the year 1992, what is the difference between the CO2 emissions (% of total fuel combustion) in Switzerland and CO2 emissions (% of total fuel combustion) in United Arab Emirates?
Your answer should be compact. 13.78. In the year 1993, what is the difference between the CO2 emissions (% of total fuel combustion) of Ecuador and CO2 emissions (% of total fuel combustion) of Macedonia?
Provide a short and direct response. 39.86. In the year 1993, what is the difference between the CO2 emissions (% of total fuel combustion) of Ecuador and CO2 emissions (% of total fuel combustion) of Switzerland?
Give a very brief answer. 22.94. In the year 1993, what is the difference between the CO2 emissions (% of total fuel combustion) in Ecuador and CO2 emissions (% of total fuel combustion) in United Arab Emirates?
Your answer should be very brief. 35.89. In the year 1993, what is the difference between the CO2 emissions (% of total fuel combustion) in Macedonia and CO2 emissions (% of total fuel combustion) in Switzerland?
Give a very brief answer. -16.92. In the year 1993, what is the difference between the CO2 emissions (% of total fuel combustion) in Macedonia and CO2 emissions (% of total fuel combustion) in United Arab Emirates?
Give a very brief answer. -3.97. In the year 1993, what is the difference between the CO2 emissions (% of total fuel combustion) in Switzerland and CO2 emissions (% of total fuel combustion) in United Arab Emirates?
Provide a short and direct response. 12.95. In the year 1994, what is the difference between the CO2 emissions (% of total fuel combustion) of Ecuador and CO2 emissions (% of total fuel combustion) of Macedonia?
Offer a very short reply. 45.25. In the year 1994, what is the difference between the CO2 emissions (% of total fuel combustion) of Ecuador and CO2 emissions (% of total fuel combustion) of Switzerland?
Make the answer very short. 20.98. In the year 1994, what is the difference between the CO2 emissions (% of total fuel combustion) of Ecuador and CO2 emissions (% of total fuel combustion) of United Arab Emirates?
Your response must be concise. 37.69. In the year 1994, what is the difference between the CO2 emissions (% of total fuel combustion) in Macedonia and CO2 emissions (% of total fuel combustion) in Switzerland?
Your answer should be compact. -24.27. In the year 1994, what is the difference between the CO2 emissions (% of total fuel combustion) in Macedonia and CO2 emissions (% of total fuel combustion) in United Arab Emirates?
Your answer should be very brief. -7.56. In the year 1994, what is the difference between the CO2 emissions (% of total fuel combustion) of Switzerland and CO2 emissions (% of total fuel combustion) of United Arab Emirates?
Keep it short and to the point. 16.71. In the year 1995, what is the difference between the CO2 emissions (% of total fuel combustion) of Ecuador and CO2 emissions (% of total fuel combustion) of Macedonia?
Provide a succinct answer. 37.4. In the year 1995, what is the difference between the CO2 emissions (% of total fuel combustion) of Ecuador and CO2 emissions (% of total fuel combustion) of Switzerland?
Offer a terse response. 13.9. In the year 1995, what is the difference between the CO2 emissions (% of total fuel combustion) in Ecuador and CO2 emissions (% of total fuel combustion) in United Arab Emirates?
Your answer should be very brief. 29.41. In the year 1995, what is the difference between the CO2 emissions (% of total fuel combustion) in Macedonia and CO2 emissions (% of total fuel combustion) in Switzerland?
Provide a short and direct response. -23.49. In the year 1995, what is the difference between the CO2 emissions (% of total fuel combustion) of Macedonia and CO2 emissions (% of total fuel combustion) of United Arab Emirates?
Make the answer very short. -7.99. In the year 1995, what is the difference between the CO2 emissions (% of total fuel combustion) in Switzerland and CO2 emissions (% of total fuel combustion) in United Arab Emirates?
Offer a terse response. 15.51. In the year 1996, what is the difference between the CO2 emissions (% of total fuel combustion) in Ecuador and CO2 emissions (% of total fuel combustion) in Macedonia?
Offer a terse response. 31.08. In the year 1996, what is the difference between the CO2 emissions (% of total fuel combustion) in Ecuador and CO2 emissions (% of total fuel combustion) in Switzerland?
Keep it short and to the point. 14.7. In the year 1996, what is the difference between the CO2 emissions (% of total fuel combustion) in Ecuador and CO2 emissions (% of total fuel combustion) in United Arab Emirates?
Provide a short and direct response. 31.22. In the year 1996, what is the difference between the CO2 emissions (% of total fuel combustion) of Macedonia and CO2 emissions (% of total fuel combustion) of Switzerland?
Offer a very short reply. -16.39. In the year 1996, what is the difference between the CO2 emissions (% of total fuel combustion) of Macedonia and CO2 emissions (% of total fuel combustion) of United Arab Emirates?
Give a very brief answer. 0.14. In the year 1996, what is the difference between the CO2 emissions (% of total fuel combustion) of Switzerland and CO2 emissions (% of total fuel combustion) of United Arab Emirates?
Provide a short and direct response. 16.53. In the year 1997, what is the difference between the CO2 emissions (% of total fuel combustion) in Ecuador and CO2 emissions (% of total fuel combustion) in Macedonia?
Ensure brevity in your answer.  32.37. In the year 1997, what is the difference between the CO2 emissions (% of total fuel combustion) in Ecuador and CO2 emissions (% of total fuel combustion) in Switzerland?
Your response must be concise. 13.71. In the year 1997, what is the difference between the CO2 emissions (% of total fuel combustion) in Ecuador and CO2 emissions (% of total fuel combustion) in United Arab Emirates?
Your response must be concise. 32.3. In the year 1997, what is the difference between the CO2 emissions (% of total fuel combustion) in Macedonia and CO2 emissions (% of total fuel combustion) in Switzerland?
Your answer should be very brief. -18.66. In the year 1997, what is the difference between the CO2 emissions (% of total fuel combustion) of Macedonia and CO2 emissions (% of total fuel combustion) of United Arab Emirates?
Your answer should be very brief. -0.07. In the year 1997, what is the difference between the CO2 emissions (% of total fuel combustion) of Switzerland and CO2 emissions (% of total fuel combustion) of United Arab Emirates?
Offer a very short reply. 18.59. What is the ratio of the CO2 emissions (% of total fuel combustion) of Ecuador in 1991 to that in 1992?
Ensure brevity in your answer.  1.05. What is the ratio of the CO2 emissions (% of total fuel combustion) of Switzerland in 1991 to that in 1992?
Your answer should be compact. 0.98. What is the ratio of the CO2 emissions (% of total fuel combustion) in United Arab Emirates in 1991 to that in 1992?
Your answer should be very brief. 0.94. What is the ratio of the CO2 emissions (% of total fuel combustion) in Ecuador in 1991 to that in 1993?
Provide a succinct answer. 1. What is the ratio of the CO2 emissions (% of total fuel combustion) in Macedonia in 1991 to that in 1993?
Keep it short and to the point. 0.56. What is the ratio of the CO2 emissions (% of total fuel combustion) of United Arab Emirates in 1991 to that in 1993?
Give a very brief answer. 0.93. What is the ratio of the CO2 emissions (% of total fuel combustion) of Ecuador in 1991 to that in 1994?
Offer a terse response. 1. What is the ratio of the CO2 emissions (% of total fuel combustion) of Macedonia in 1991 to that in 1994?
Your answer should be compact. 0.83. What is the ratio of the CO2 emissions (% of total fuel combustion) in Switzerland in 1991 to that in 1994?
Offer a terse response. 0.95. What is the ratio of the CO2 emissions (% of total fuel combustion) of United Arab Emirates in 1991 to that in 1994?
Give a very brief answer. 1.03. What is the ratio of the CO2 emissions (% of total fuel combustion) in Ecuador in 1991 to that in 1995?
Provide a short and direct response. 1.18. What is the ratio of the CO2 emissions (% of total fuel combustion) in Macedonia in 1991 to that in 1995?
Provide a short and direct response. 0.89. What is the ratio of the CO2 emissions (% of total fuel combustion) of United Arab Emirates in 1991 to that in 1995?
Your response must be concise. 1.04. What is the ratio of the CO2 emissions (% of total fuel combustion) in Ecuador in 1991 to that in 1996?
Offer a very short reply. 1.18. What is the ratio of the CO2 emissions (% of total fuel combustion) of Macedonia in 1991 to that in 1996?
Offer a very short reply. 0.55. What is the ratio of the CO2 emissions (% of total fuel combustion) in Switzerland in 1991 to that in 1996?
Keep it short and to the point. 1.01. What is the ratio of the CO2 emissions (% of total fuel combustion) of United Arab Emirates in 1991 to that in 1996?
Ensure brevity in your answer.  1.15. What is the ratio of the CO2 emissions (% of total fuel combustion) of Ecuador in 1991 to that in 1997?
Offer a terse response. 1.15. What is the ratio of the CO2 emissions (% of total fuel combustion) of Macedonia in 1991 to that in 1997?
Offer a terse response. 0.56. What is the ratio of the CO2 emissions (% of total fuel combustion) in Switzerland in 1991 to that in 1997?
Your answer should be very brief. 0.95. What is the ratio of the CO2 emissions (% of total fuel combustion) of United Arab Emirates in 1991 to that in 1997?
Provide a short and direct response. 1.14. What is the ratio of the CO2 emissions (% of total fuel combustion) in Ecuador in 1992 to that in 1993?
Ensure brevity in your answer.  0.95. What is the ratio of the CO2 emissions (% of total fuel combustion) in Macedonia in 1992 to that in 1993?
Ensure brevity in your answer.  0.56. What is the ratio of the CO2 emissions (% of total fuel combustion) in Switzerland in 1992 to that in 1993?
Provide a succinct answer. 1.02. What is the ratio of the CO2 emissions (% of total fuel combustion) of United Arab Emirates in 1992 to that in 1993?
Offer a terse response. 0.99. What is the ratio of the CO2 emissions (% of total fuel combustion) of Ecuador in 1992 to that in 1994?
Keep it short and to the point. 0.95. What is the ratio of the CO2 emissions (% of total fuel combustion) in Macedonia in 1992 to that in 1994?
Offer a very short reply. 0.84. What is the ratio of the CO2 emissions (% of total fuel combustion) of Switzerland in 1992 to that in 1994?
Offer a very short reply. 0.97. What is the ratio of the CO2 emissions (% of total fuel combustion) of United Arab Emirates in 1992 to that in 1994?
Ensure brevity in your answer.  1.09. What is the ratio of the CO2 emissions (% of total fuel combustion) of Ecuador in 1992 to that in 1995?
Your answer should be very brief. 1.12. What is the ratio of the CO2 emissions (% of total fuel combustion) of Macedonia in 1992 to that in 1995?
Provide a short and direct response. 0.89. What is the ratio of the CO2 emissions (% of total fuel combustion) in Switzerland in 1992 to that in 1995?
Ensure brevity in your answer.  1.01. What is the ratio of the CO2 emissions (% of total fuel combustion) in United Arab Emirates in 1992 to that in 1995?
Provide a succinct answer. 1.11. What is the ratio of the CO2 emissions (% of total fuel combustion) in Ecuador in 1992 to that in 1996?
Provide a succinct answer. 1.12. What is the ratio of the CO2 emissions (% of total fuel combustion) in Macedonia in 1992 to that in 1996?
Keep it short and to the point. 0.56. What is the ratio of the CO2 emissions (% of total fuel combustion) in Switzerland in 1992 to that in 1996?
Your answer should be very brief. 1.03. What is the ratio of the CO2 emissions (% of total fuel combustion) of United Arab Emirates in 1992 to that in 1996?
Provide a succinct answer. 1.22. What is the ratio of the CO2 emissions (% of total fuel combustion) of Ecuador in 1992 to that in 1997?
Your response must be concise. 1.09. What is the ratio of the CO2 emissions (% of total fuel combustion) of Macedonia in 1992 to that in 1997?
Offer a terse response. 0.56. What is the ratio of the CO2 emissions (% of total fuel combustion) of Switzerland in 1992 to that in 1997?
Ensure brevity in your answer.  0.97. What is the ratio of the CO2 emissions (% of total fuel combustion) in United Arab Emirates in 1992 to that in 1997?
Offer a very short reply. 1.21. What is the ratio of the CO2 emissions (% of total fuel combustion) of Macedonia in 1993 to that in 1994?
Give a very brief answer. 1.5. What is the ratio of the CO2 emissions (% of total fuel combustion) of Switzerland in 1993 to that in 1994?
Give a very brief answer. 0.95. What is the ratio of the CO2 emissions (% of total fuel combustion) of United Arab Emirates in 1993 to that in 1994?
Give a very brief answer. 1.11. What is the ratio of the CO2 emissions (% of total fuel combustion) of Ecuador in 1993 to that in 1995?
Ensure brevity in your answer.  1.18. What is the ratio of the CO2 emissions (% of total fuel combustion) of Macedonia in 1993 to that in 1995?
Offer a terse response. 1.59. What is the ratio of the CO2 emissions (% of total fuel combustion) of Switzerland in 1993 to that in 1995?
Keep it short and to the point. 0.99. What is the ratio of the CO2 emissions (% of total fuel combustion) of United Arab Emirates in 1993 to that in 1995?
Your answer should be compact. 1.12. What is the ratio of the CO2 emissions (% of total fuel combustion) in Ecuador in 1993 to that in 1996?
Provide a short and direct response. 1.18. What is the ratio of the CO2 emissions (% of total fuel combustion) of Macedonia in 1993 to that in 1996?
Your answer should be very brief. 0.99. What is the ratio of the CO2 emissions (% of total fuel combustion) in Switzerland in 1993 to that in 1996?
Provide a short and direct response. 1.01. What is the ratio of the CO2 emissions (% of total fuel combustion) in United Arab Emirates in 1993 to that in 1996?
Offer a very short reply. 1.23. What is the ratio of the CO2 emissions (% of total fuel combustion) of Ecuador in 1993 to that in 1997?
Make the answer very short. 1.15. What is the ratio of the CO2 emissions (% of total fuel combustion) of Switzerland in 1993 to that in 1997?
Give a very brief answer. 0.95. What is the ratio of the CO2 emissions (% of total fuel combustion) in United Arab Emirates in 1993 to that in 1997?
Provide a short and direct response. 1.23. What is the ratio of the CO2 emissions (% of total fuel combustion) in Ecuador in 1994 to that in 1995?
Your answer should be very brief. 1.18. What is the ratio of the CO2 emissions (% of total fuel combustion) in Macedonia in 1994 to that in 1995?
Make the answer very short. 1.06. What is the ratio of the CO2 emissions (% of total fuel combustion) in Switzerland in 1994 to that in 1995?
Your answer should be very brief. 1.04. What is the ratio of the CO2 emissions (% of total fuel combustion) of United Arab Emirates in 1994 to that in 1995?
Make the answer very short. 1.01. What is the ratio of the CO2 emissions (% of total fuel combustion) of Ecuador in 1994 to that in 1996?
Give a very brief answer. 1.17. What is the ratio of the CO2 emissions (% of total fuel combustion) in Macedonia in 1994 to that in 1996?
Ensure brevity in your answer.  0.66. What is the ratio of the CO2 emissions (% of total fuel combustion) in Switzerland in 1994 to that in 1996?
Offer a very short reply. 1.06. What is the ratio of the CO2 emissions (% of total fuel combustion) in United Arab Emirates in 1994 to that in 1996?
Offer a terse response. 1.11. What is the ratio of the CO2 emissions (% of total fuel combustion) of Ecuador in 1994 to that in 1997?
Provide a succinct answer. 1.15. What is the ratio of the CO2 emissions (% of total fuel combustion) of Macedonia in 1994 to that in 1997?
Make the answer very short. 0.67. What is the ratio of the CO2 emissions (% of total fuel combustion) in United Arab Emirates in 1994 to that in 1997?
Give a very brief answer. 1.11. What is the ratio of the CO2 emissions (% of total fuel combustion) in Macedonia in 1995 to that in 1996?
Your answer should be very brief. 0.62. What is the ratio of the CO2 emissions (% of total fuel combustion) of Switzerland in 1995 to that in 1996?
Your answer should be very brief. 1.02. What is the ratio of the CO2 emissions (% of total fuel combustion) of United Arab Emirates in 1995 to that in 1996?
Offer a very short reply. 1.1. What is the ratio of the CO2 emissions (% of total fuel combustion) of Ecuador in 1995 to that in 1997?
Make the answer very short. 0.97. What is the ratio of the CO2 emissions (% of total fuel combustion) in Macedonia in 1995 to that in 1997?
Give a very brief answer. 0.63. What is the ratio of the CO2 emissions (% of total fuel combustion) in Switzerland in 1995 to that in 1997?
Provide a short and direct response. 0.96. What is the ratio of the CO2 emissions (% of total fuel combustion) of United Arab Emirates in 1995 to that in 1997?
Provide a succinct answer. 1.09. What is the ratio of the CO2 emissions (% of total fuel combustion) of Ecuador in 1996 to that in 1997?
Your answer should be very brief. 0.98. What is the ratio of the CO2 emissions (% of total fuel combustion) in Macedonia in 1996 to that in 1997?
Keep it short and to the point. 1.01. What is the ratio of the CO2 emissions (% of total fuel combustion) of Switzerland in 1996 to that in 1997?
Give a very brief answer. 0.94. What is the ratio of the CO2 emissions (% of total fuel combustion) of United Arab Emirates in 1996 to that in 1997?
Provide a short and direct response. 0.99. What is the difference between the highest and the second highest CO2 emissions (% of total fuel combustion) in Ecuador?
Your answer should be compact. 0.06. What is the difference between the highest and the second highest CO2 emissions (% of total fuel combustion) in Macedonia?
Make the answer very short. 0.1. What is the difference between the highest and the second highest CO2 emissions (% of total fuel combustion) in Switzerland?
Provide a succinct answer. 0.07. What is the difference between the highest and the second highest CO2 emissions (% of total fuel combustion) of United Arab Emirates?
Give a very brief answer. 0.26. What is the difference between the highest and the lowest CO2 emissions (% of total fuel combustion) of Ecuador?
Keep it short and to the point. 8.75. What is the difference between the highest and the lowest CO2 emissions (% of total fuel combustion) of Macedonia?
Provide a succinct answer. 7.65. What is the difference between the highest and the lowest CO2 emissions (% of total fuel combustion) of Switzerland?
Keep it short and to the point. 2.17. What is the difference between the highest and the lowest CO2 emissions (% of total fuel combustion) of United Arab Emirates?
Your response must be concise. 3.95. 